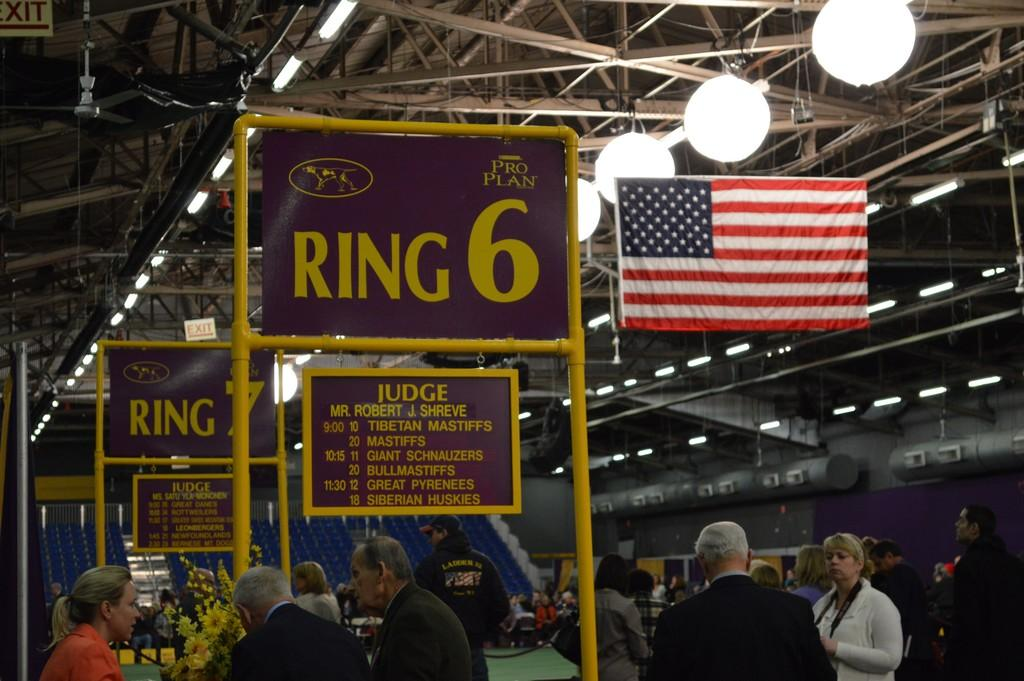How many people are in the image? There is a group of people in the image, but the exact number is not specified. What are the people in the image doing? Some people are standing, while others are sitting on chairs. What decorative item can be seen in the image? There is a flower bouquet in the image. What type of lighting is visible in the image? There are lights visible in the image. What symbolic item is present in the image? There is a flag in the image. What type of signage is present in the image? There are boards present in the image. What structural element is visible in the image? Iron rods are visible in the image. What type of furniture is present in the image? Chairs are present in the image. What type of cake is being served at the event in the image? There is no cake present in the image. How many hands are visible in the image? The number of hands visible in the image is not specified. What type of pin is being used to hold the flag in the image? There is no pin visible in the image; the flag is simply present. 